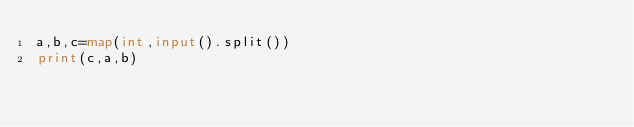<code> <loc_0><loc_0><loc_500><loc_500><_Python_>a,b,c=map(int,input().split())
print(c,a,b)</code> 